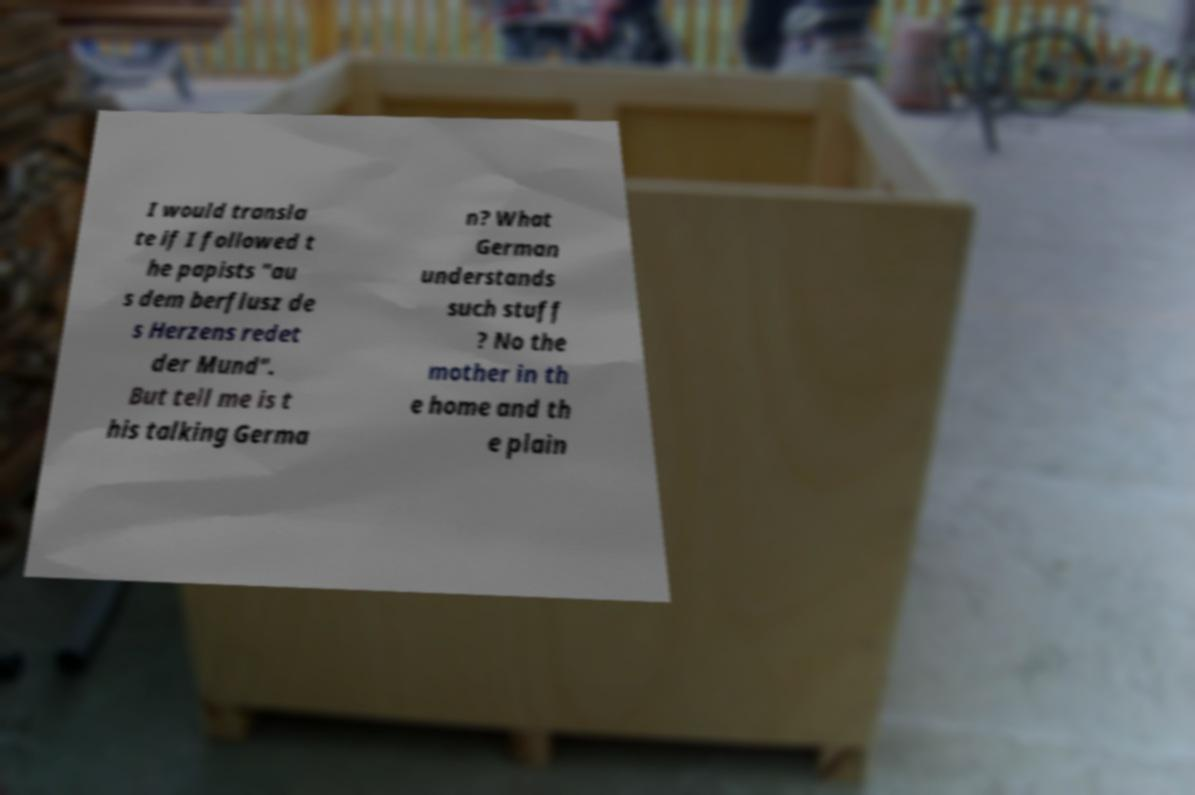For documentation purposes, I need the text within this image transcribed. Could you provide that? I would transla te if I followed t he papists "au s dem berflusz de s Herzens redet der Mund". But tell me is t his talking Germa n? What German understands such stuff ? No the mother in th e home and th e plain 